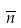<formula> <loc_0><loc_0><loc_500><loc_500>\overline { n }</formula> 